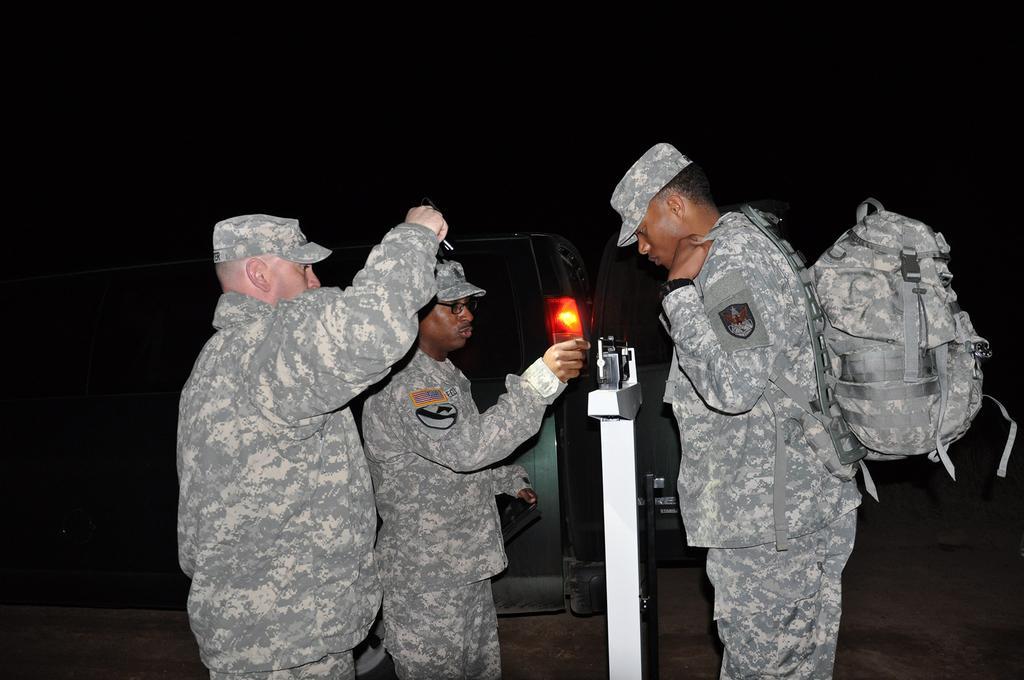Describe this image in one or two sentences. This 3 persons are standing. This 3 persons wore military dress and cap. This person is carrying a bag. Far there is a vehicle. 